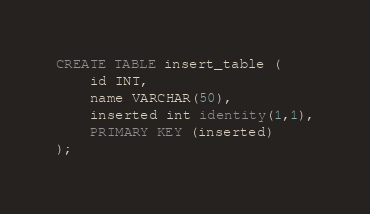Convert code to text. <code><loc_0><loc_0><loc_500><loc_500><_SQL_>CREATE TABLE insert_table (
	id INT,
	name VARCHAR(50),
	inserted int identity(1,1),
    PRIMARY KEY (inserted)
);</code> 